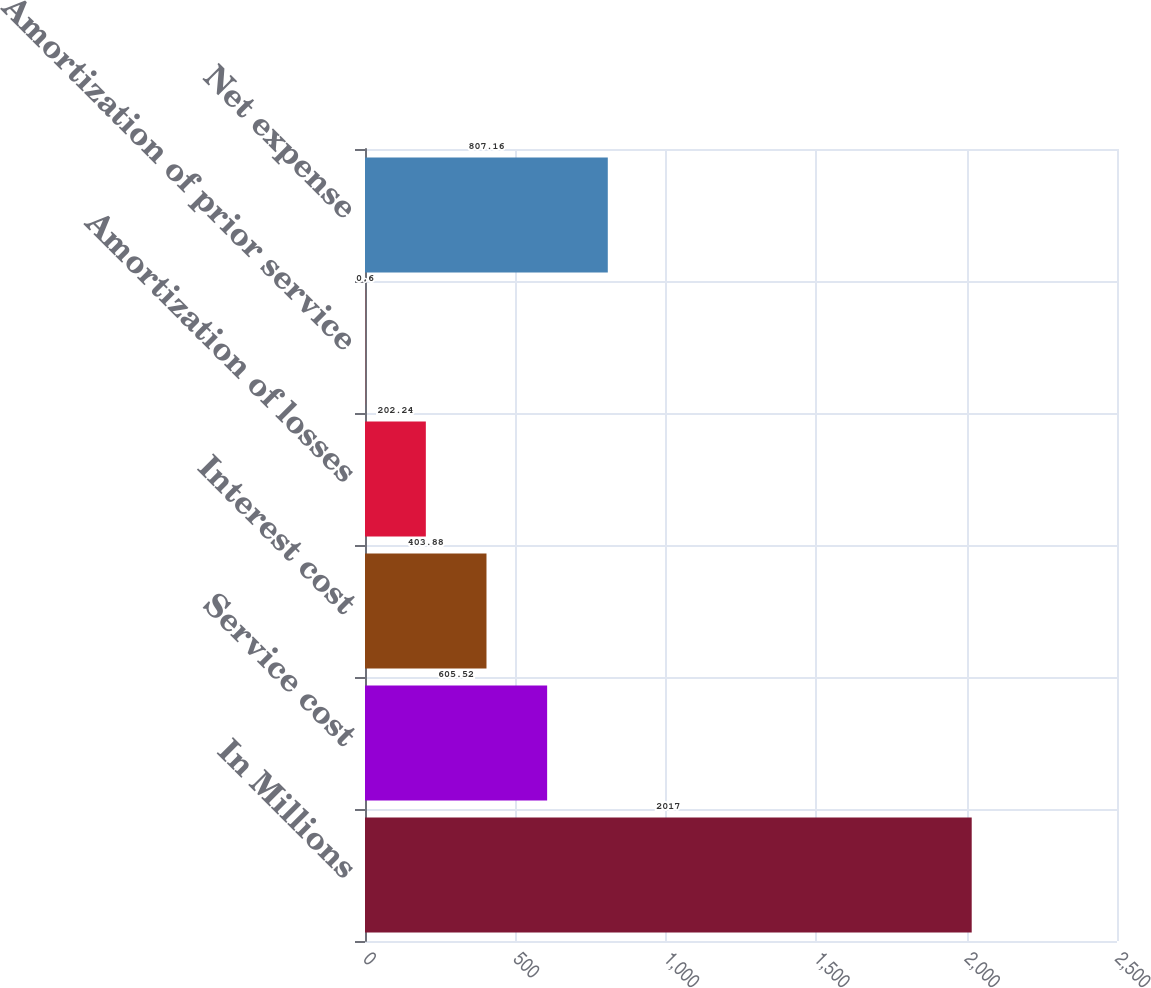Convert chart to OTSL. <chart><loc_0><loc_0><loc_500><loc_500><bar_chart><fcel>In Millions<fcel>Service cost<fcel>Interest cost<fcel>Amortization of losses<fcel>Amortization of prior service<fcel>Net expense<nl><fcel>2017<fcel>605.52<fcel>403.88<fcel>202.24<fcel>0.6<fcel>807.16<nl></chart> 